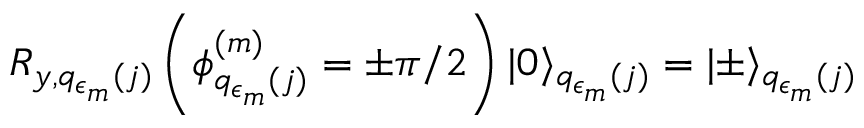<formula> <loc_0><loc_0><loc_500><loc_500>R _ { y , q _ { \epsilon _ { m } } ( j ) } \left ( \phi _ { q _ { \epsilon _ { m } } ( j ) } ^ { ( m ) } = \pm \pi / 2 \right ) | 0 \rangle _ { q _ { \epsilon _ { m } } ( j ) } = | \pm \rangle _ { q _ { \epsilon _ { m } } ( j ) }</formula> 